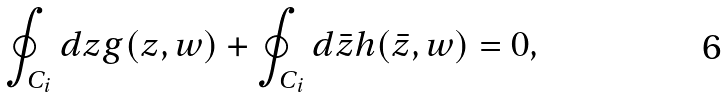Convert formula to latex. <formula><loc_0><loc_0><loc_500><loc_500>\oint _ { C _ { i } } d z g ( z , w ) + \oint _ { C _ { i } } d \bar { z } h ( \bar { z } , w ) = 0 ,</formula> 